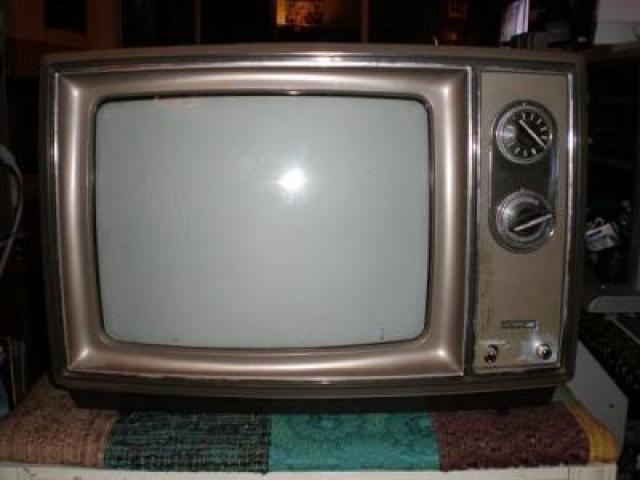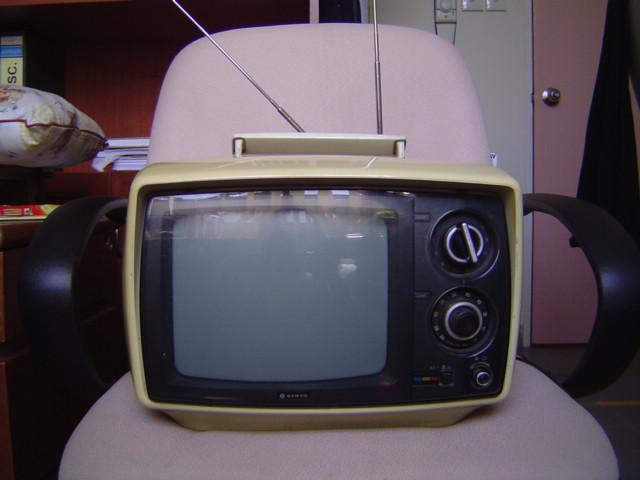The first image is the image on the left, the second image is the image on the right. Examine the images to the left and right. Is the description "One of the images shows a video game controller near a television." accurate? Answer yes or no. No. The first image is the image on the left, the second image is the image on the right. Evaluate the accuracy of this statement regarding the images: "One TV has a handle projecting from the top, and the other TV has an orange case and sits on a table by a game controller.". Is it true? Answer yes or no. No. 